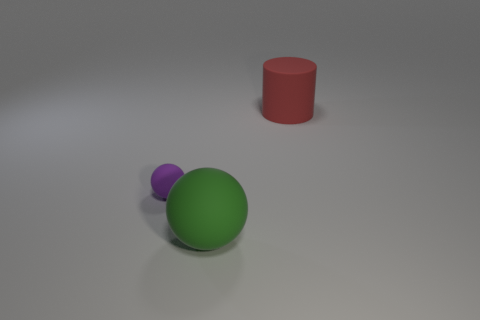Add 2 big blue metallic cubes. How many objects exist? 5 Subtract all spheres. How many objects are left? 1 Subtract 1 purple balls. How many objects are left? 2 Subtract all green cylinders. Subtract all green blocks. How many cylinders are left? 1 Subtract all tiny cyan shiny things. Subtract all rubber cylinders. How many objects are left? 2 Add 1 cylinders. How many cylinders are left? 2 Add 1 big purple matte objects. How many big purple matte objects exist? 1 